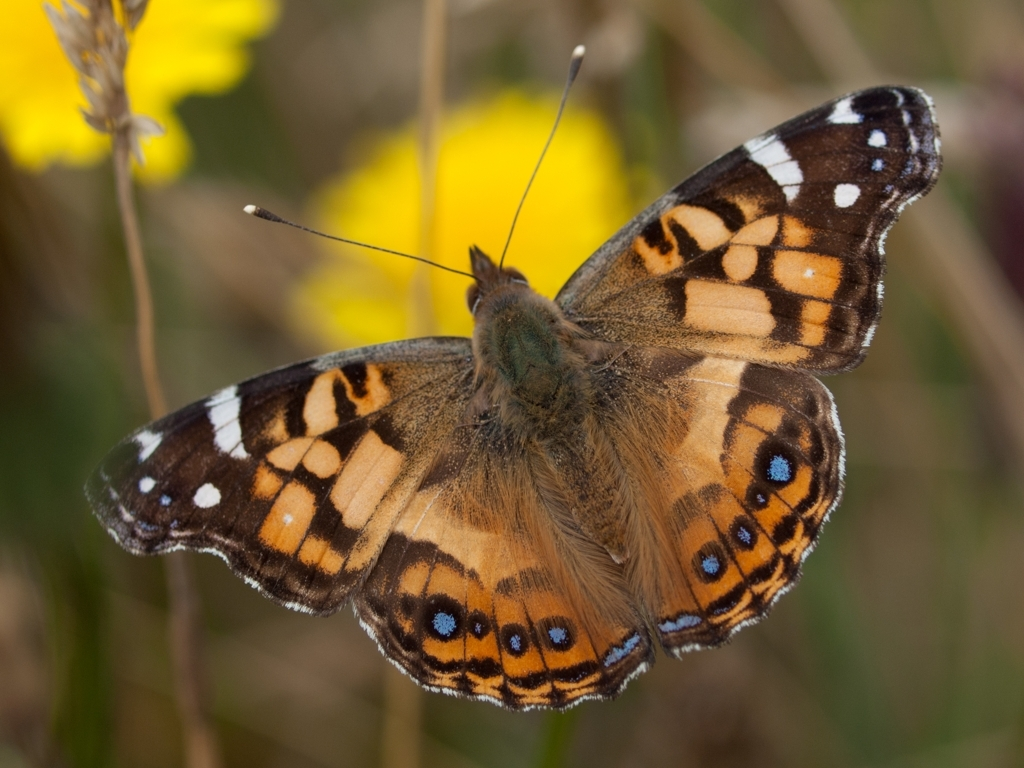What species might this butterfly be and can you determine its gender? This appears to be a painted lady butterfly, identifiable by its orange, brown, and black wing pattern with eye spots on the hindwings. Determining the gender of a butterfly from an image can be challenging as it often requires close examination of physical characteristics not clearly visible in photos, such as the presence of scent scales or differences in wing size. Is there anything particularly special about the painted lady butterfly? Painted lady butterflies are indeed special for several reasons. They are one of the most widespread of all butterfly species, found on every continent except Antarctica. Remarkably, they undertake long migrations, which is a testament to their resilience and ability to adapt to diverse environments. 